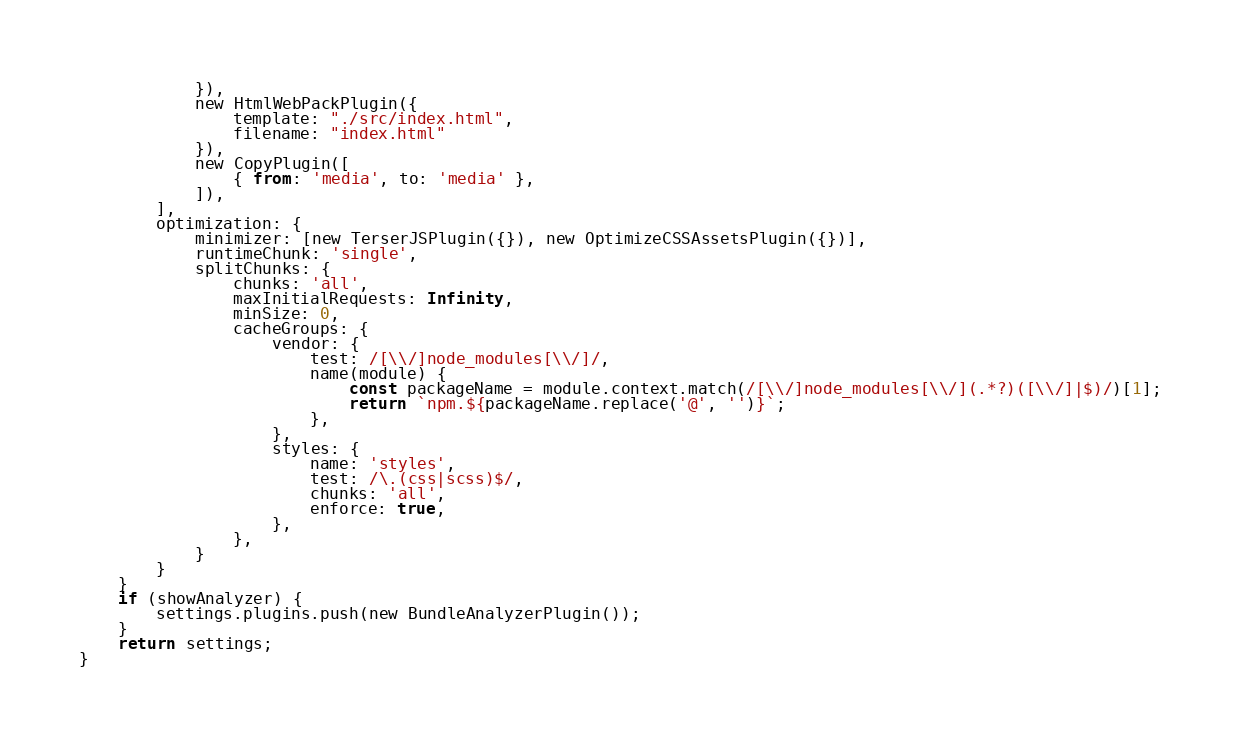<code> <loc_0><loc_0><loc_500><loc_500><_JavaScript_>            }),
            new HtmlWebPackPlugin({
                template: "./src/index.html",
                filename: "index.html"
            }),
            new CopyPlugin([
                { from: 'media', to: 'media' },
            ]),
        ],
        optimization: {
            minimizer: [new TerserJSPlugin({}), new OptimizeCSSAssetsPlugin({})],
            runtimeChunk: 'single',
            splitChunks: {
                chunks: 'all',
                maxInitialRequests: Infinity,
                minSize: 0,
                cacheGroups: {
                    vendor: {
                        test: /[\\/]node_modules[\\/]/,
                        name(module) {
                            const packageName = module.context.match(/[\\/]node_modules[\\/](.*?)([\\/]|$)/)[1];
                            return `npm.${packageName.replace('@', '')}`;
                        },
                    },
                    styles: {
                        name: 'styles',
                        test: /\.(css|scss)$/,
                        chunks: 'all',
                        enforce: true,
                    },
                },
            }
        }
    }
    if (showAnalyzer) {
        settings.plugins.push(new BundleAnalyzerPlugin());
    }
    return settings;
}</code> 